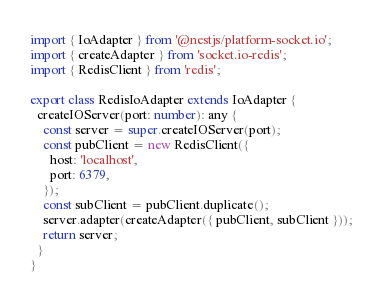<code> <loc_0><loc_0><loc_500><loc_500><_TypeScript_>import { IoAdapter } from '@nestjs/platform-socket.io';
import { createAdapter } from 'socket.io-redis';
import { RedisClient } from 'redis';

export class RedisIoAdapter extends IoAdapter {
  createIOServer(port: number): any {
    const server = super.createIOServer(port);
    const pubClient = new RedisClient({
      host: 'localhost',
      port: 6379,
    });
    const subClient = pubClient.duplicate();
    server.adapter(createAdapter({ pubClient, subClient }));
    return server;
  }
}
</code> 